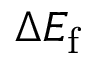<formula> <loc_0><loc_0><loc_500><loc_500>\Delta E _ { f }</formula> 